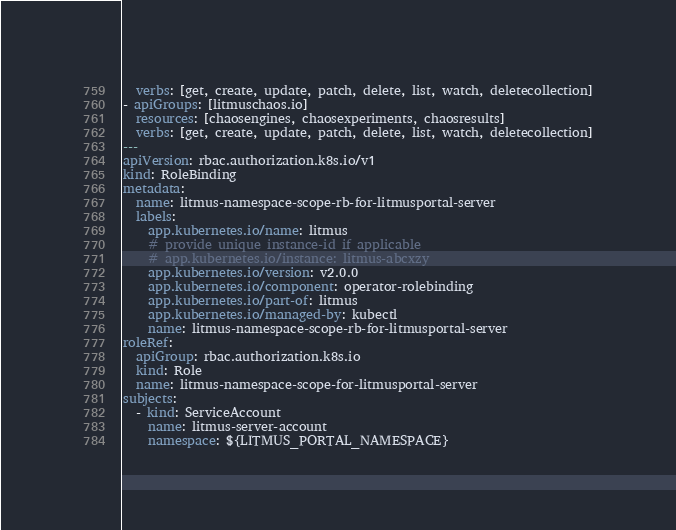<code> <loc_0><loc_0><loc_500><loc_500><_YAML_>  verbs: [get, create, update, patch, delete, list, watch, deletecollection]
- apiGroups: [litmuschaos.io]
  resources: [chaosengines, chaosexperiments, chaosresults]
  verbs: [get, create, update, patch, delete, list, watch, deletecollection]
---
apiVersion: rbac.authorization.k8s.io/v1
kind: RoleBinding
metadata:
  name: litmus-namespace-scope-rb-for-litmusportal-server
  labels:
    app.kubernetes.io/name: litmus
    # provide unique instance-id if applicable
    # app.kubernetes.io/instance: litmus-abcxzy
    app.kubernetes.io/version: v2.0.0
    app.kubernetes.io/component: operator-rolebinding
    app.kubernetes.io/part-of: litmus
    app.kubernetes.io/managed-by: kubectl
    name: litmus-namespace-scope-rb-for-litmusportal-server
roleRef:
  apiGroup: rbac.authorization.k8s.io
  kind: Role
  name: litmus-namespace-scope-for-litmusportal-server
subjects:
  - kind: ServiceAccount
    name: litmus-server-account
    namespace: ${LITMUS_PORTAL_NAMESPACE}</code> 